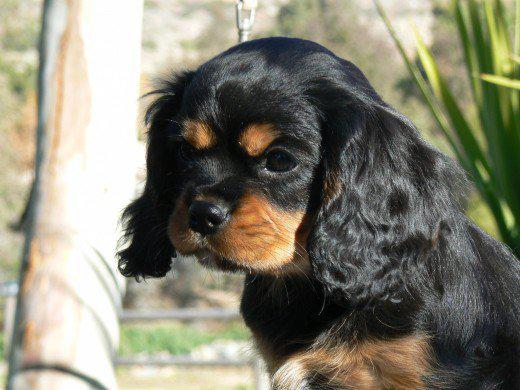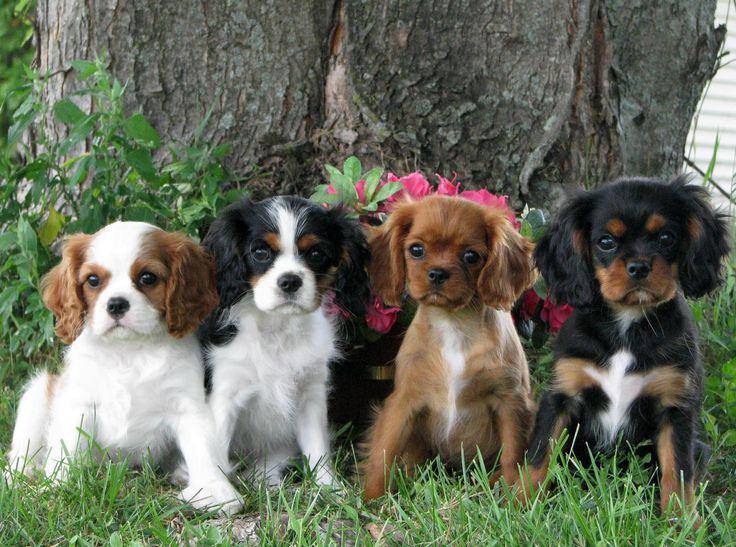The first image is the image on the left, the second image is the image on the right. Considering the images on both sides, is "A horizontal row of four spaniels in similar poses includes dogs of different colors." valid? Answer yes or no. Yes. The first image is the image on the left, the second image is the image on the right. Given the left and right images, does the statement "The right image contains exactly four dogs seated in a horizontal row." hold true? Answer yes or no. Yes. 